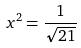Convert formula to latex. <formula><loc_0><loc_0><loc_500><loc_500>x ^ { 2 } = \frac { 1 } { \sqrt { 2 1 } }</formula> 